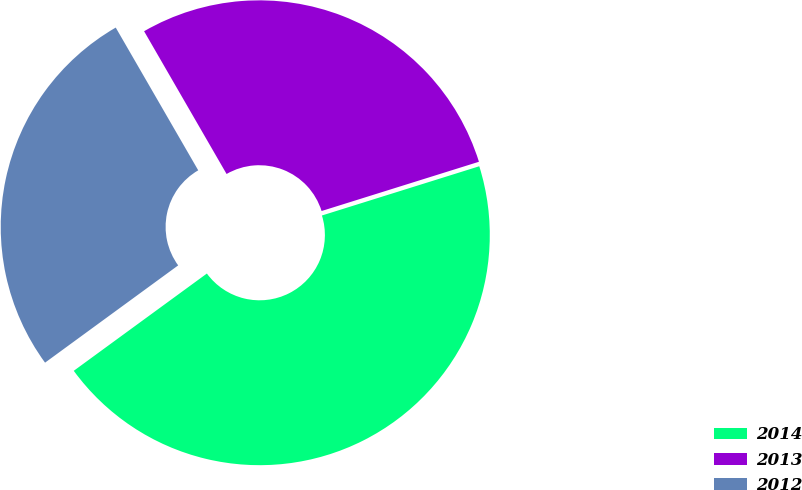Convert chart to OTSL. <chart><loc_0><loc_0><loc_500><loc_500><pie_chart><fcel>2014<fcel>2013<fcel>2012<nl><fcel>44.78%<fcel>28.51%<fcel>26.7%<nl></chart> 